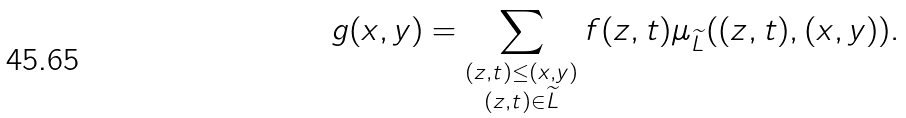Convert formula to latex. <formula><loc_0><loc_0><loc_500><loc_500>g ( x , y ) = \sum _ { \substack { ( z , t ) \leq ( x , y ) \\ ( z , t ) \in \widetilde { L } } } f ( z , t ) \mu _ { \widetilde { L } } ( ( z , t ) , ( x , y ) ) .</formula> 